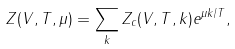<formula> <loc_0><loc_0><loc_500><loc_500>Z ( V , T , \mu ) = \sum _ { k } Z _ { c } ( V , T , k ) e ^ { \mu k / T } ,</formula> 